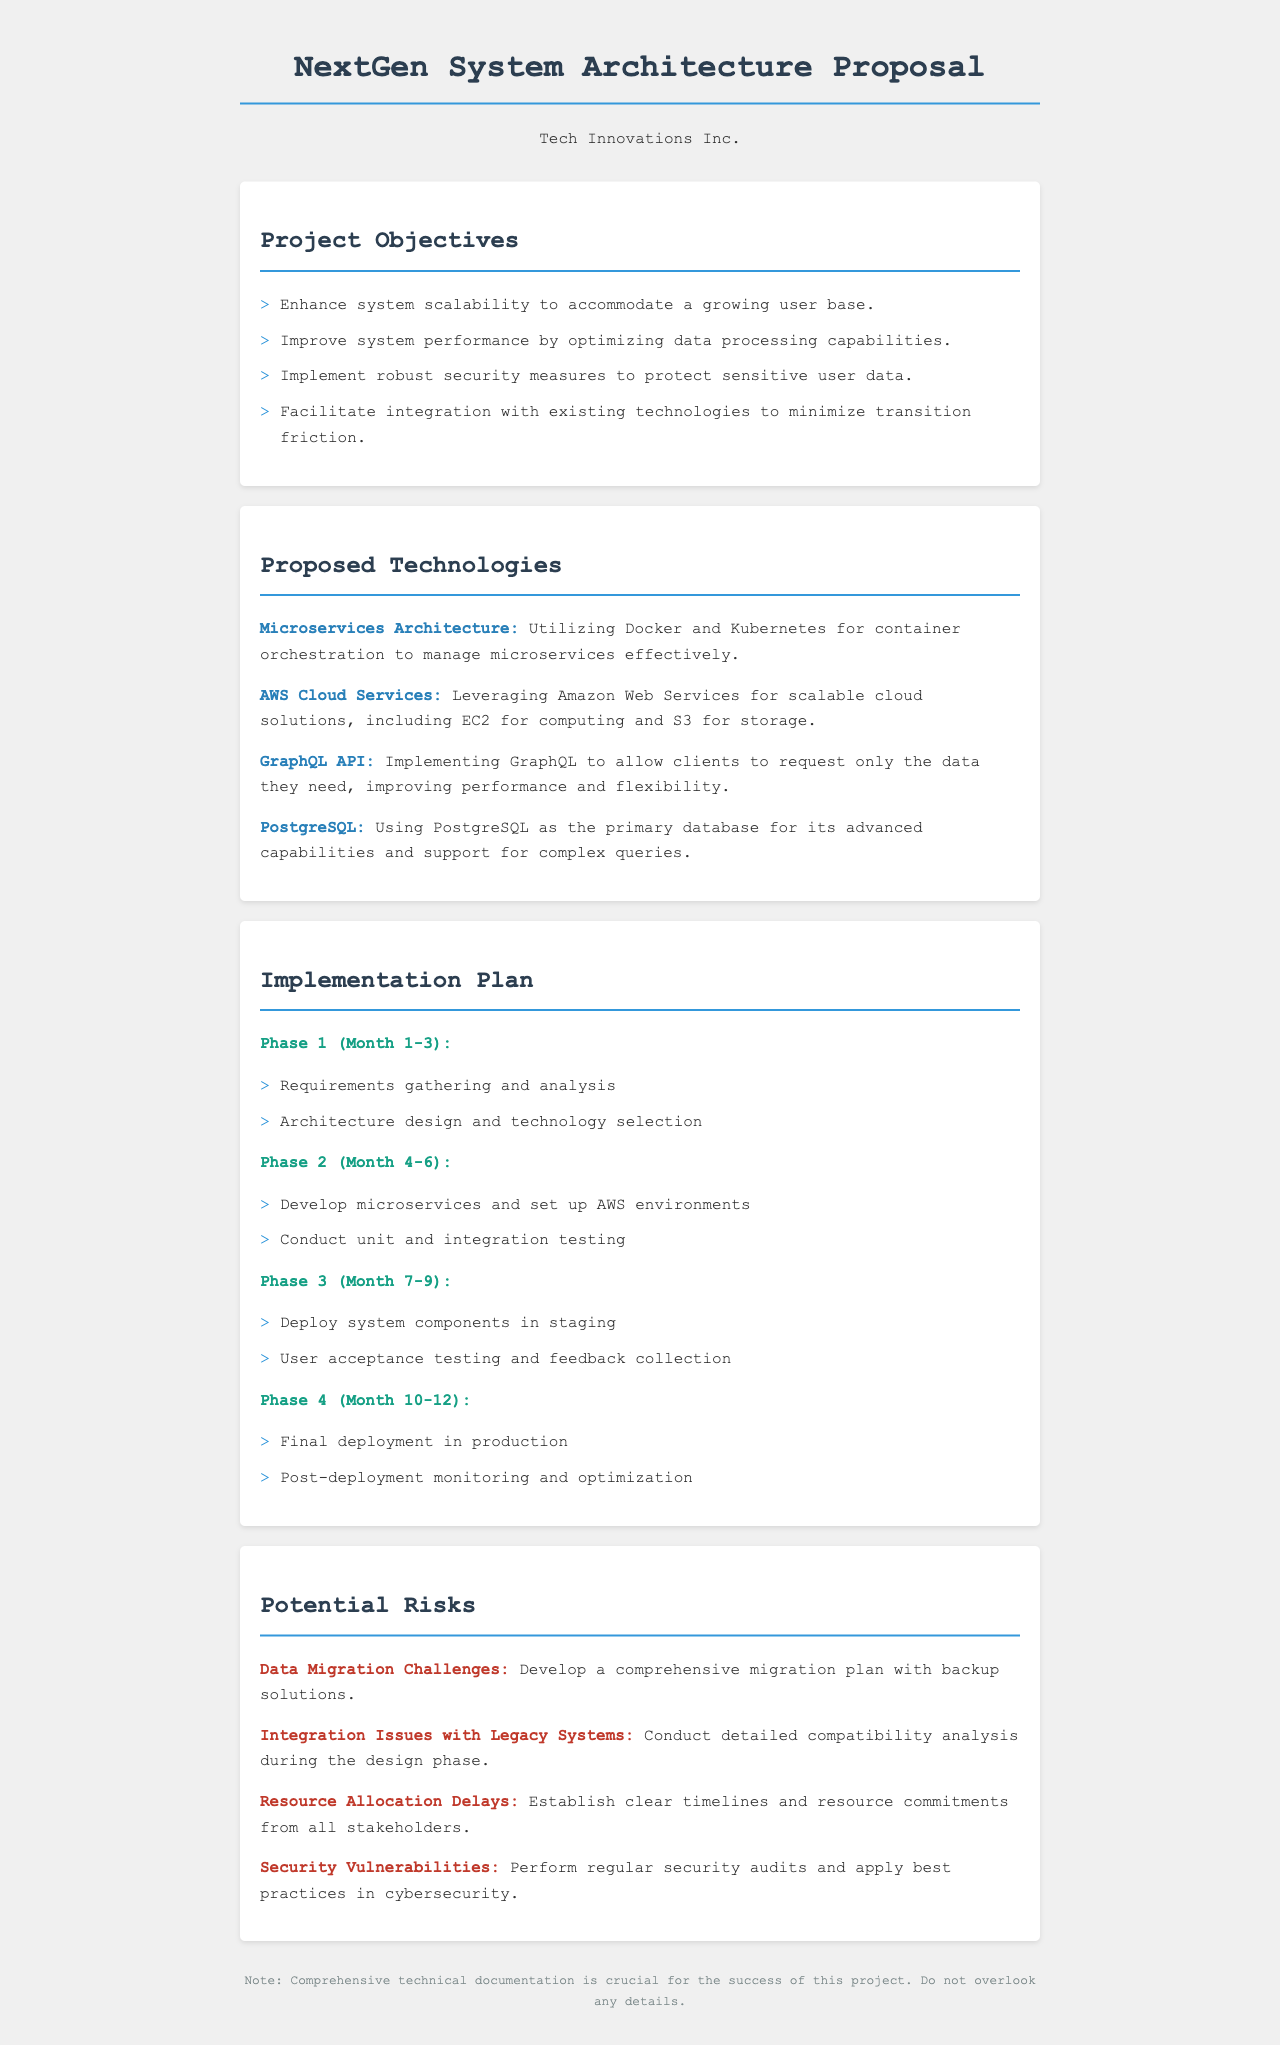What are the project objectives? The project objectives are listed in the document, which include enhancing system scalability, improving system performance, implementing security measures, and facilitating integration.
Answer: Enhance system scalability to accommodate a growing user base What is the main database used in the proposed technologies? The main database mentioned in the document is PostgreSQL, chosen for its advanced capabilities.
Answer: PostgreSQL How long is the implementation phase expected to last? The implementation plan covers a total of twelve months divided into four phases.
Answer: 12 months What are security vulnerabilities addressed in the potential risks? The document highlights the importance of performing regular security audits to address security vulnerabilities.
Answer: Security vulnerabilities Which phase involves user acceptance testing? Phase 3 is specified as the period for deploying system components in staging and conducting user acceptance testing.
Answer: Phase 3 What technology is used for container orchestration? The proposed technology for container orchestration, mentioned in the document, is Kubernetes.
Answer: Kubernetes How many phases are outlined in the implementation plan? The implementation plan consists of four distinct phases.
Answer: 4 What is the expected outcome after final deployment? The final outcome after deployment includes post-deployment monitoring and optimization.
Answer: Post-deployment monitoring and optimization 